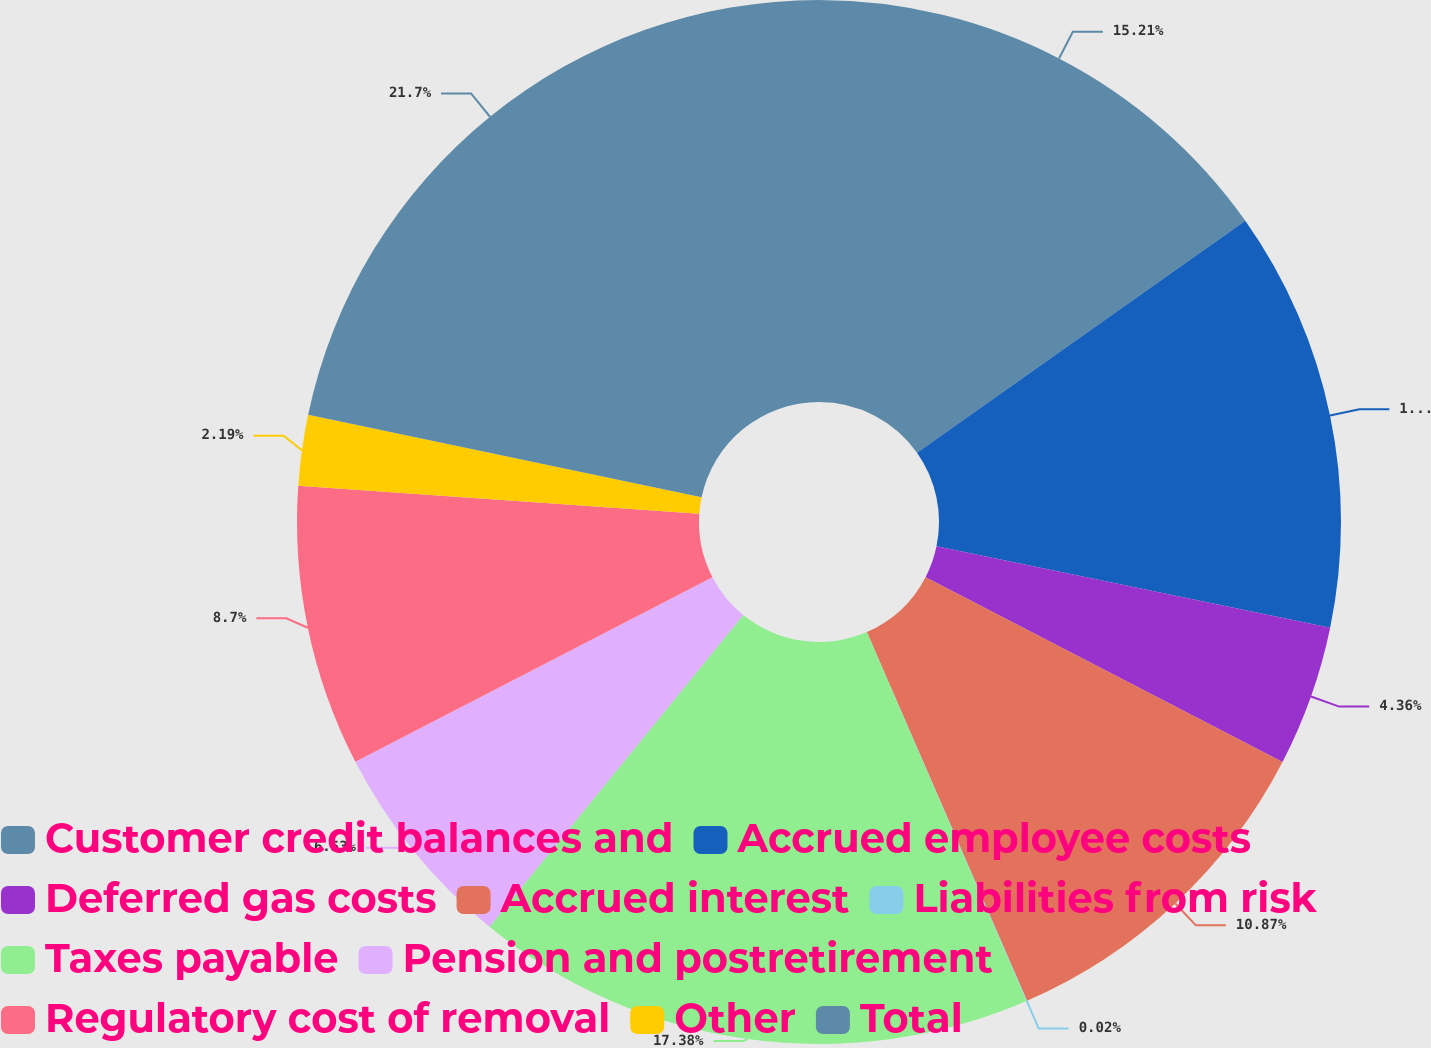<chart> <loc_0><loc_0><loc_500><loc_500><pie_chart><fcel>Customer credit balances and<fcel>Accrued employee costs<fcel>Deferred gas costs<fcel>Accrued interest<fcel>Liabilities from risk<fcel>Taxes payable<fcel>Pension and postretirement<fcel>Regulatory cost of removal<fcel>Other<fcel>Total<nl><fcel>15.21%<fcel>13.04%<fcel>4.36%<fcel>10.87%<fcel>0.02%<fcel>17.38%<fcel>6.53%<fcel>8.7%<fcel>2.19%<fcel>21.71%<nl></chart> 